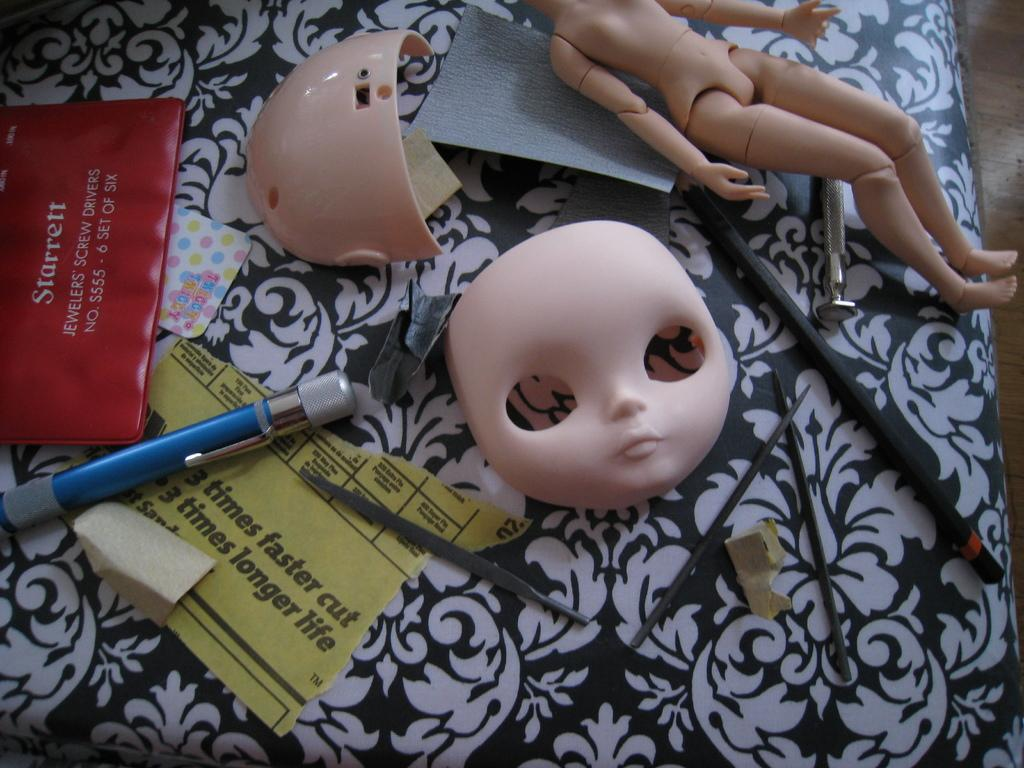What is the main subject of the image? There is a doll in the image. What can be seen near the doll? There is a pen and papers visible in the image. Are there any specific parts of the doll that can be seen? Yes, there are parts of a doll visible in the image. What other objects are present on the black and white surface in the image? There are other objects on a black and white surface in the image. What type of soup is being served in the image? There is no soup present in the image. How many balls can be seen in the image? There are no balls visible in the image. 